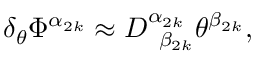<formula> <loc_0><loc_0><loc_500><loc_500>\delta _ { \theta } \Phi ^ { \alpha _ { 2 k } } \approx D _ { \, \beta _ { 2 k } } ^ { \alpha _ { 2 k } } \theta ^ { \beta _ { 2 k } } ,</formula> 